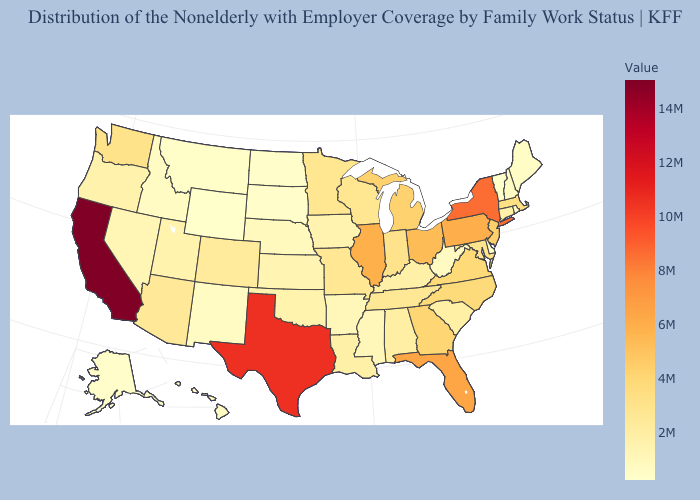Does Tennessee have the lowest value in the USA?
Concise answer only. No. Among the states that border Georgia , which have the highest value?
Keep it brief. Florida. Does New Hampshire have a lower value than Wisconsin?
Quick response, please. Yes. Does New York have the highest value in the Northeast?
Short answer required. Yes. Among the states that border New Jersey , does Delaware have the lowest value?
Keep it brief. Yes. 